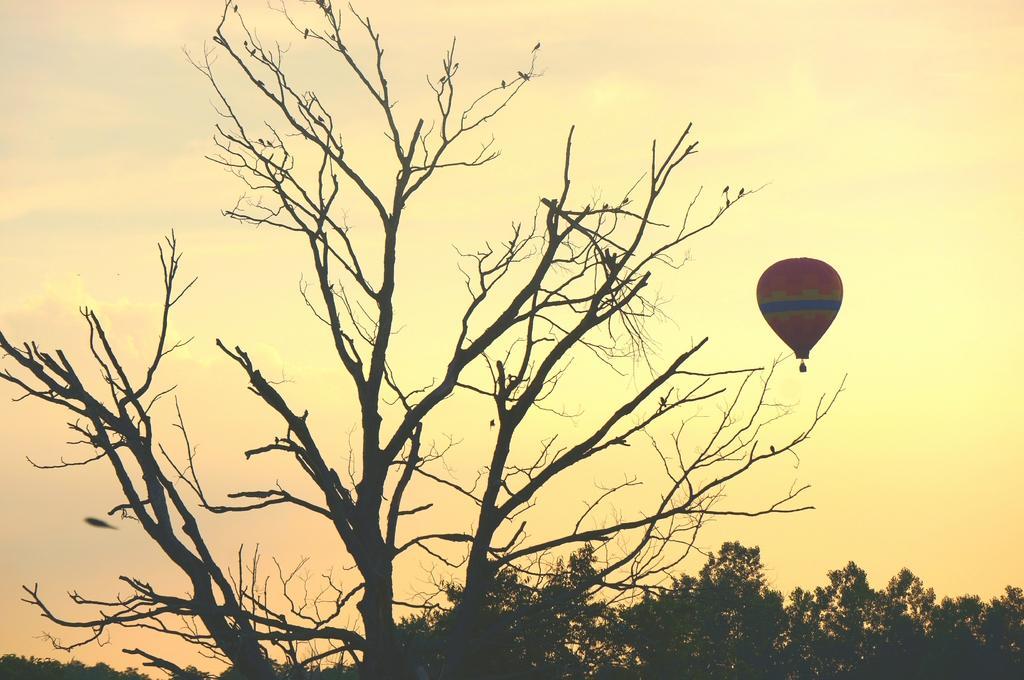Can you describe this image briefly? In this picture we can see birds, trees and hot air balloon in the air. In the background of the image we can see the sky. 